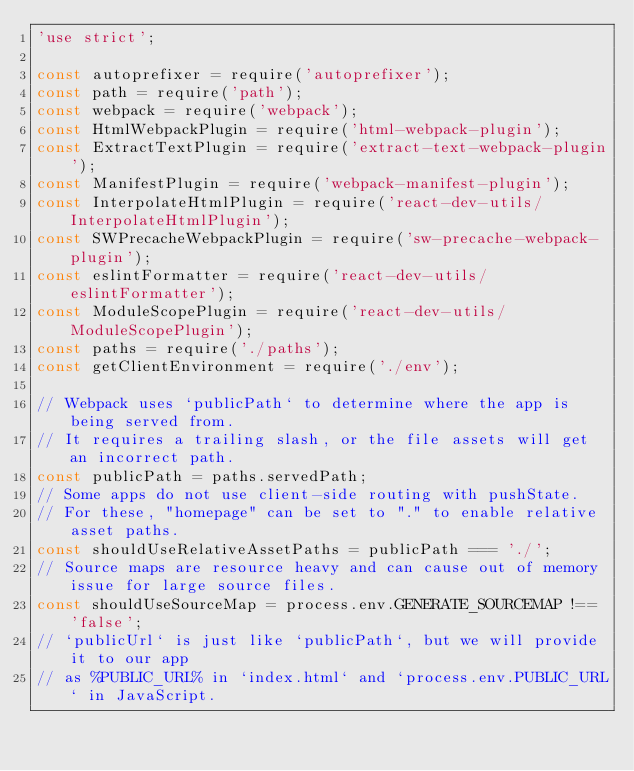Convert code to text. <code><loc_0><loc_0><loc_500><loc_500><_JavaScript_>'use strict';

const autoprefixer = require('autoprefixer');
const path = require('path');
const webpack = require('webpack');
const HtmlWebpackPlugin = require('html-webpack-plugin');
const ExtractTextPlugin = require('extract-text-webpack-plugin');
const ManifestPlugin = require('webpack-manifest-plugin');
const InterpolateHtmlPlugin = require('react-dev-utils/InterpolateHtmlPlugin');
const SWPrecacheWebpackPlugin = require('sw-precache-webpack-plugin');
const eslintFormatter = require('react-dev-utils/eslintFormatter');
const ModuleScopePlugin = require('react-dev-utils/ModuleScopePlugin');
const paths = require('./paths');
const getClientEnvironment = require('./env');

// Webpack uses `publicPath` to determine where the app is being served from.
// It requires a trailing slash, or the file assets will get an incorrect path.
const publicPath = paths.servedPath;
// Some apps do not use client-side routing with pushState.
// For these, "homepage" can be set to "." to enable relative asset paths.
const shouldUseRelativeAssetPaths = publicPath === './';
// Source maps are resource heavy and can cause out of memory issue for large source files.
const shouldUseSourceMap = process.env.GENERATE_SOURCEMAP !== 'false';
// `publicUrl` is just like `publicPath`, but we will provide it to our app
// as %PUBLIC_URL% in `index.html` and `process.env.PUBLIC_URL` in JavaScript.</code> 